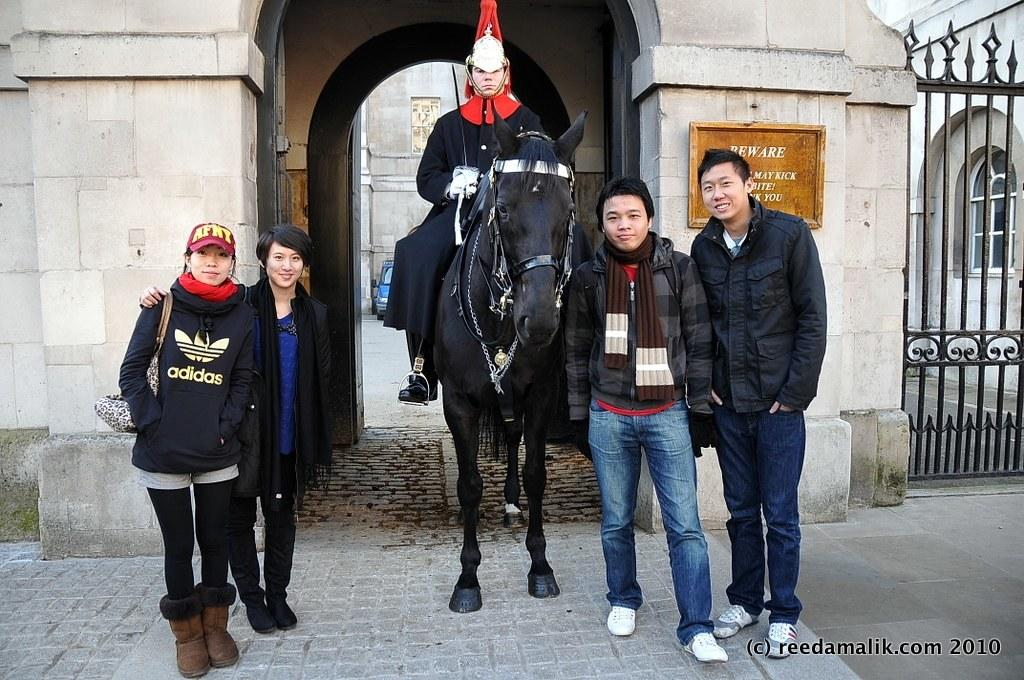How many people are in the image? There is a group of people in the image. What is the position of the people in the image? The people are standing on the ground. Can you describe the man in the image? The man is sitting on a horse. What type of destruction can be seen in the image? There is no destruction present in the image; it features a group of people and a man sitting on a horse. What is the man arguing about with the people in the image? There is no argument present in the image; the man is simply sitting on a horse. 